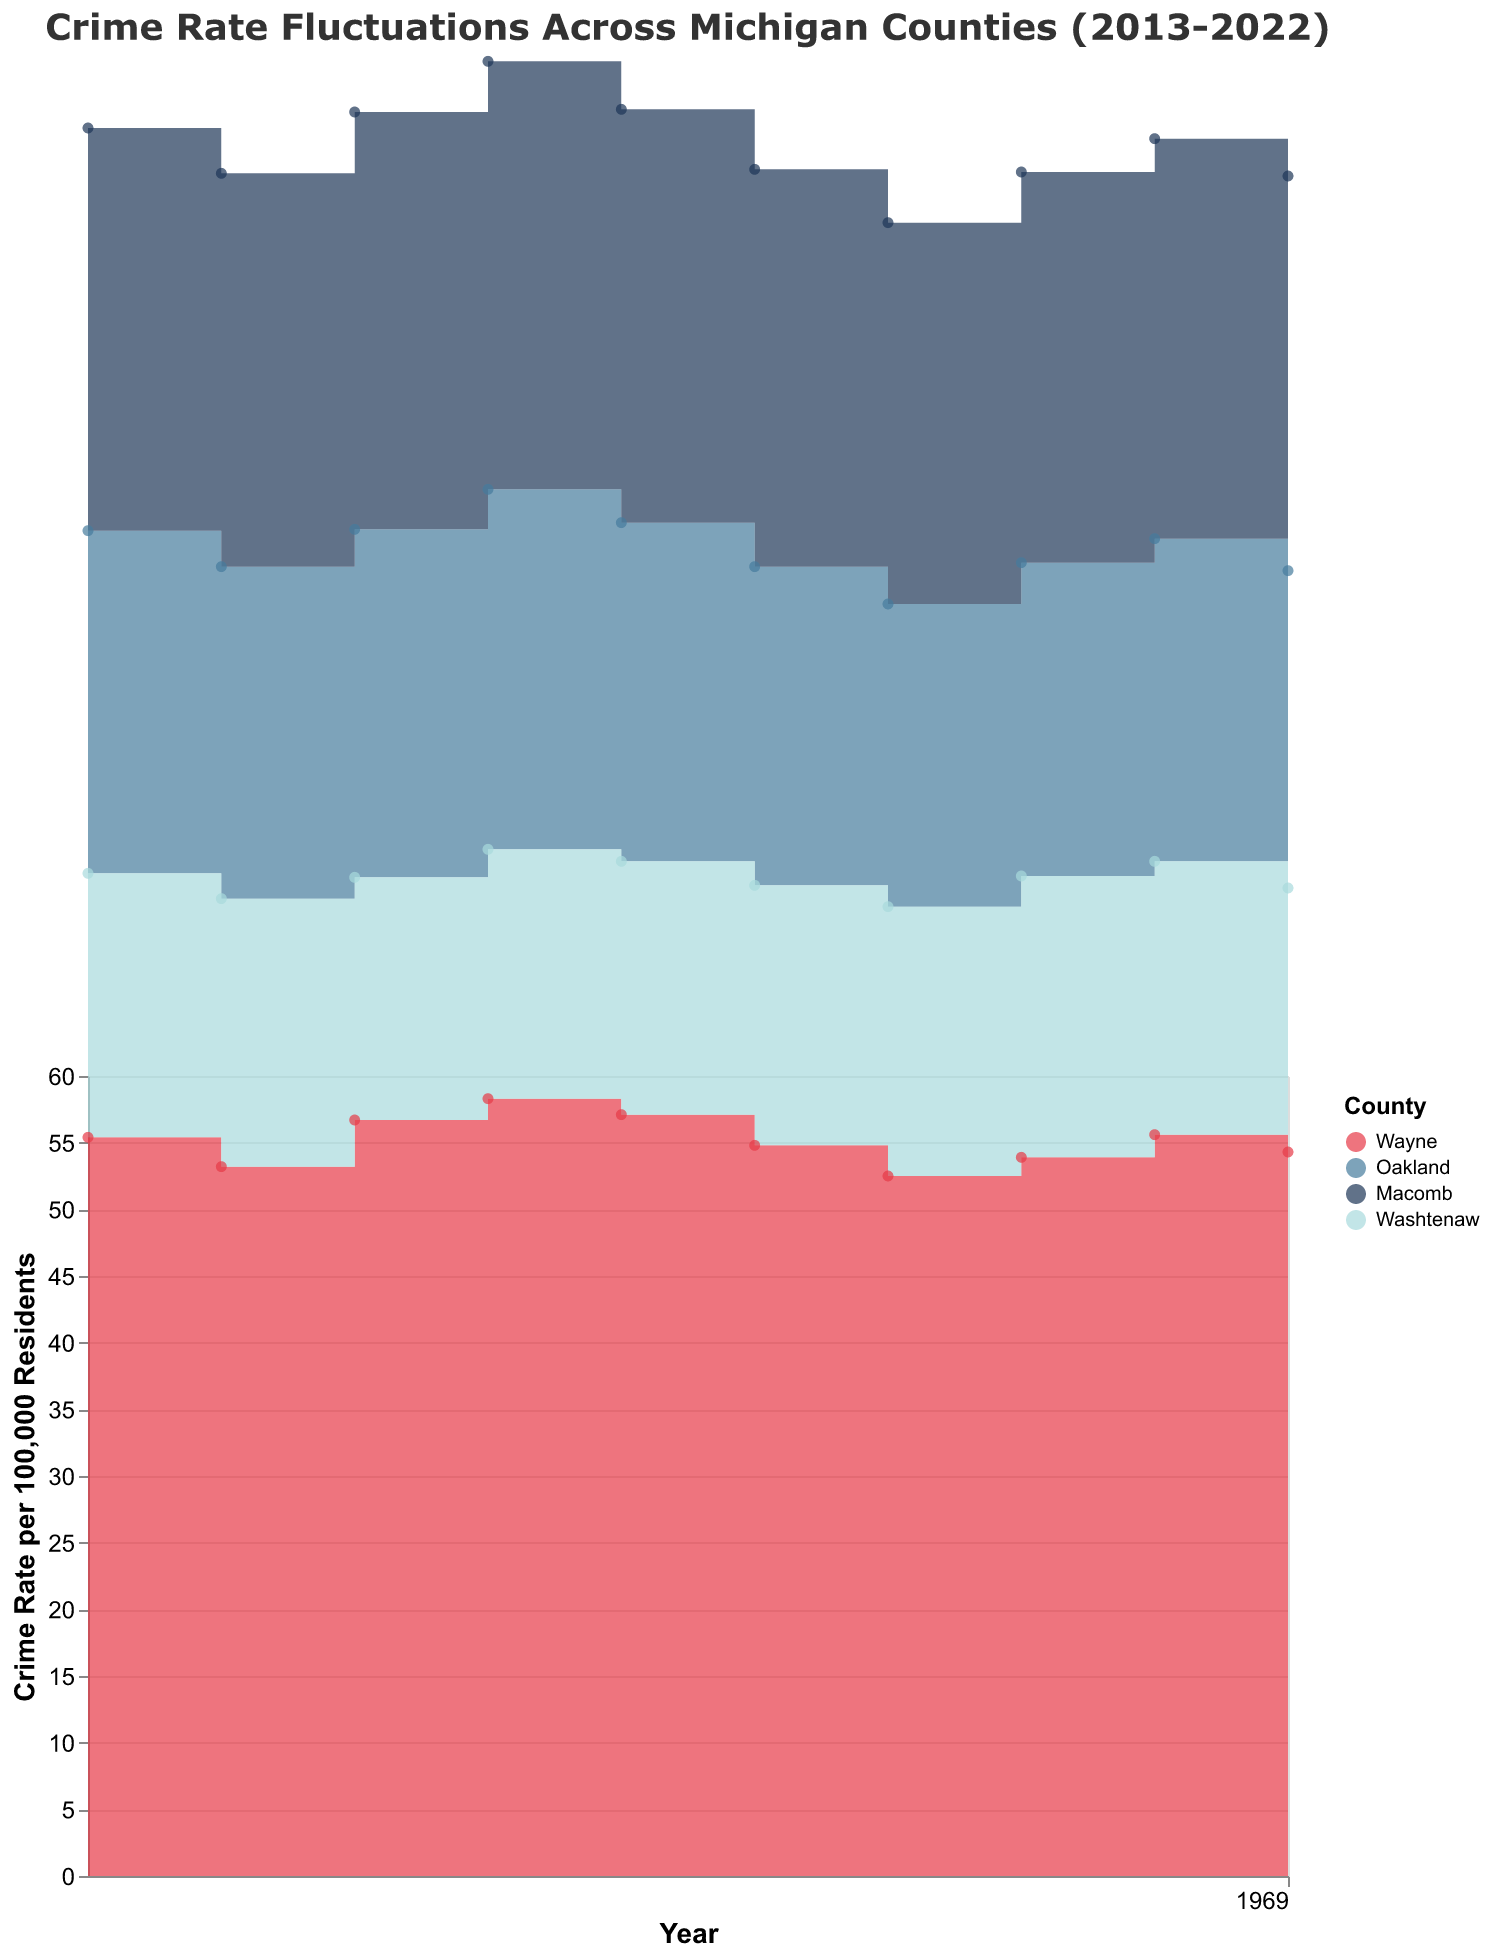What is the highest crime rate recorded in Wayne County over the past decade? By inspecting the step area chart, locate the segment corresponding to Wayne County and identify the highest peak in the area representing crime rates over time.
Answer: 58.3 What is the general trend in crime rates in Oakland County from 2013 to 2022? By analyzing the step area chart, observe the general direction (upward or downward) of the crime rate line for Oakland County over the specified period.
Answer: Decreasing How did the crime rate in Washtenaw County in 2020 compare to that in 2022? Locate the data points for Washtenaw County in 2020 and 2022, then compare their heights to assess the change in crime rate.
Answer: Higher in 2020 Which county saw the most significant increase in crime rate in a single year, and what was the value? Check the step area chart for the sharpest upward step among all counties, indicating the largest annual increase in crime rate.
Answer: Wayne County, from 2014 to 2015 Looking at Macomb County, did crime rates generally increase, decrease, or stay the same from 2013 to 2022? Observe the shape and direction of the area representing Macomb County throughout the decade.
Answer: Increase How did the crime rate in Wayne County fluctuate between 2013 and 2018? Follow the step area representing Wayne County from 2013 to 2018, observing the peaks and troughs.
Answer: Increased, peaked in 2016, then decreased By how much did the crime rate in Oakland County decrease from its peak in 2016 to its low in 2019? Find the highest crime rate for Oakland County in 2016 and the lowest in 2019, then subtract the latter from the former.
Answer: 27.0 - 22.7 = 4.3 Compare the overall crime rates of Wayne County to Washtenaw County over the decade. Which had higher rates on average? Calculate the average crime rate for Wayne and Washtenaw counties over the years by adding annual values and dividing by the number of years. Compare the results.
Answer: Wayne County Did the crime rate in Washtenaw County ever exceed 21 per 100,000 residents over the past decade? Inspect the step area chart for Washtenaw County to see if any portion of the area surpasses the 21 mark on the y-axis.
Answer: No 